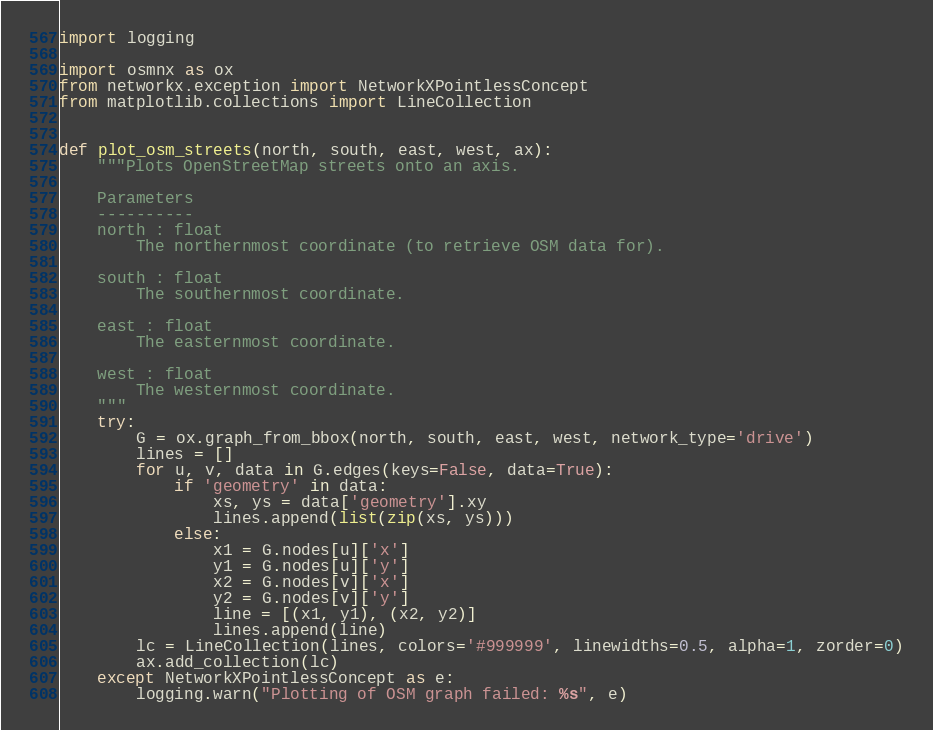<code> <loc_0><loc_0><loc_500><loc_500><_Python_>import logging

import osmnx as ox
from networkx.exception import NetworkXPointlessConcept
from matplotlib.collections import LineCollection


def plot_osm_streets(north, south, east, west, ax):
    """Plots OpenStreetMap streets onto an axis.

    Parameters
    ----------
    north : float
        The northernmost coordinate (to retrieve OSM data for).
    
    south : float
        The southernmost coordinate.

    east : float
        The easternmost coordinate.
    
    west : float
        The westernmost coordinate.
    """
    try:
        G = ox.graph_from_bbox(north, south, east, west, network_type='drive')
        lines = []
        for u, v, data in G.edges(keys=False, data=True):
            if 'geometry' in data:
                xs, ys = data['geometry'].xy
                lines.append(list(zip(xs, ys)))
            else:
                x1 = G.nodes[u]['x']
                y1 = G.nodes[u]['y']
                x2 = G.nodes[v]['x']
                y2 = G.nodes[v]['y']
                line = [(x1, y1), (x2, y2)]
                lines.append(line)
        lc = LineCollection(lines, colors='#999999', linewidths=0.5, alpha=1, zorder=0)
        ax.add_collection(lc)
    except NetworkXPointlessConcept as e:
        logging.warn("Plotting of OSM graph failed: %s", e)</code> 